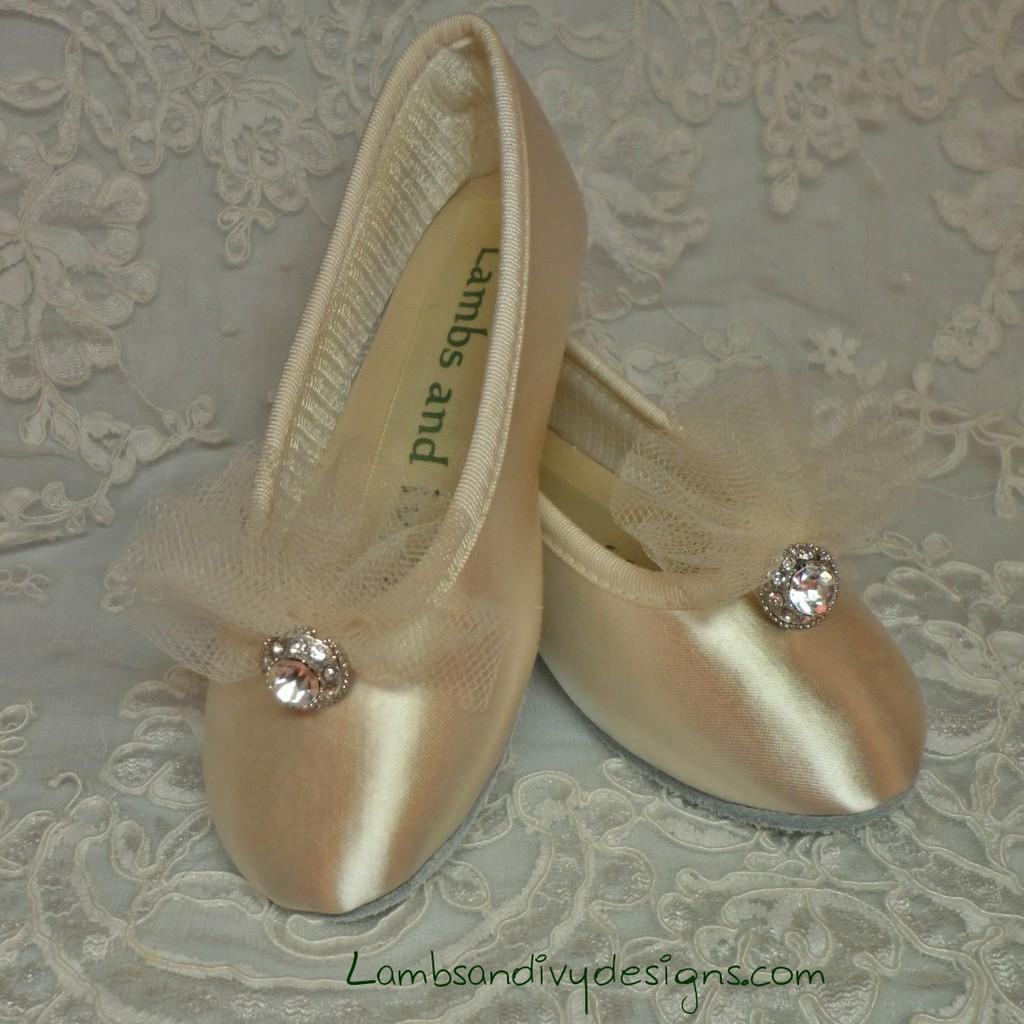What is placed on the white cloth with embroidery? There are shoes on a white cloth with embroidery. What is a noticeable feature of the shoes? The shoes have a net on them. What is placed on top of the shoes? There is a stone on the shoes. What can be seen written on the shoes? Something is written on the shoes. Can you describe any additional details about the image? There is a watermark below the shoes. What type of roof can be seen above the shoes in the image? There is no roof visible in the image; it only shows the shoes, white cloth, and other mentioned details. 